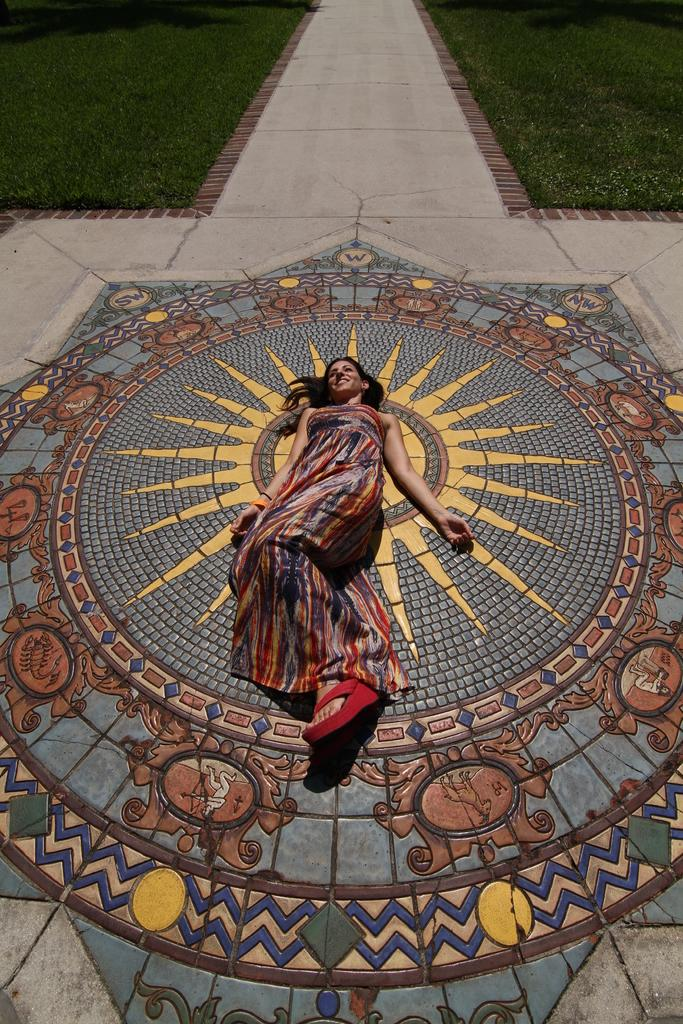Who is present in the image? There is a woman in the image. What is the woman doing in the image? The woman is on the floor and smiling. What can be seen in the background of the image? There is a path and grass visible in the background of the image. What type of argument is the woman having with the scarecrow in the image? There is no scarecrow present in the image, and therefore no argument can be observed. 